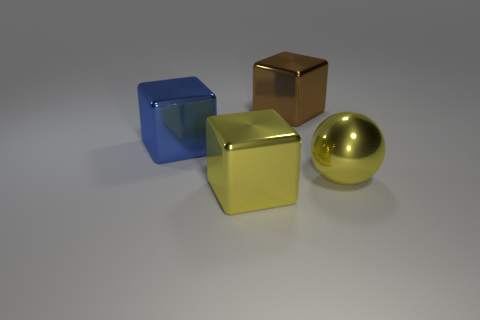Subtract all large brown metal blocks. How many blocks are left? 2 Add 1 metal objects. How many objects exist? 5 Subtract all cubes. How many objects are left? 1 Subtract 1 balls. How many balls are left? 0 Subtract all yellow blocks. Subtract all yellow cylinders. How many blocks are left? 2 Subtract all green balls. How many purple blocks are left? 0 Subtract all large yellow blocks. Subtract all tiny red cylinders. How many objects are left? 3 Add 3 big brown metal blocks. How many big brown metal blocks are left? 4 Add 2 blue things. How many blue things exist? 3 Subtract 0 red spheres. How many objects are left? 4 